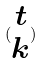<formula> <loc_0><loc_0><loc_500><loc_500>( \begin{matrix} t \\ k \end{matrix} )</formula> 